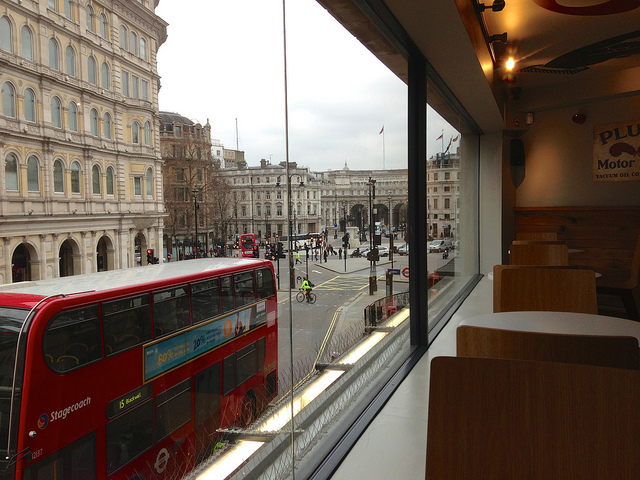Please transcribe the text in this image. PLU Motor 20 15 Stagecoocn 